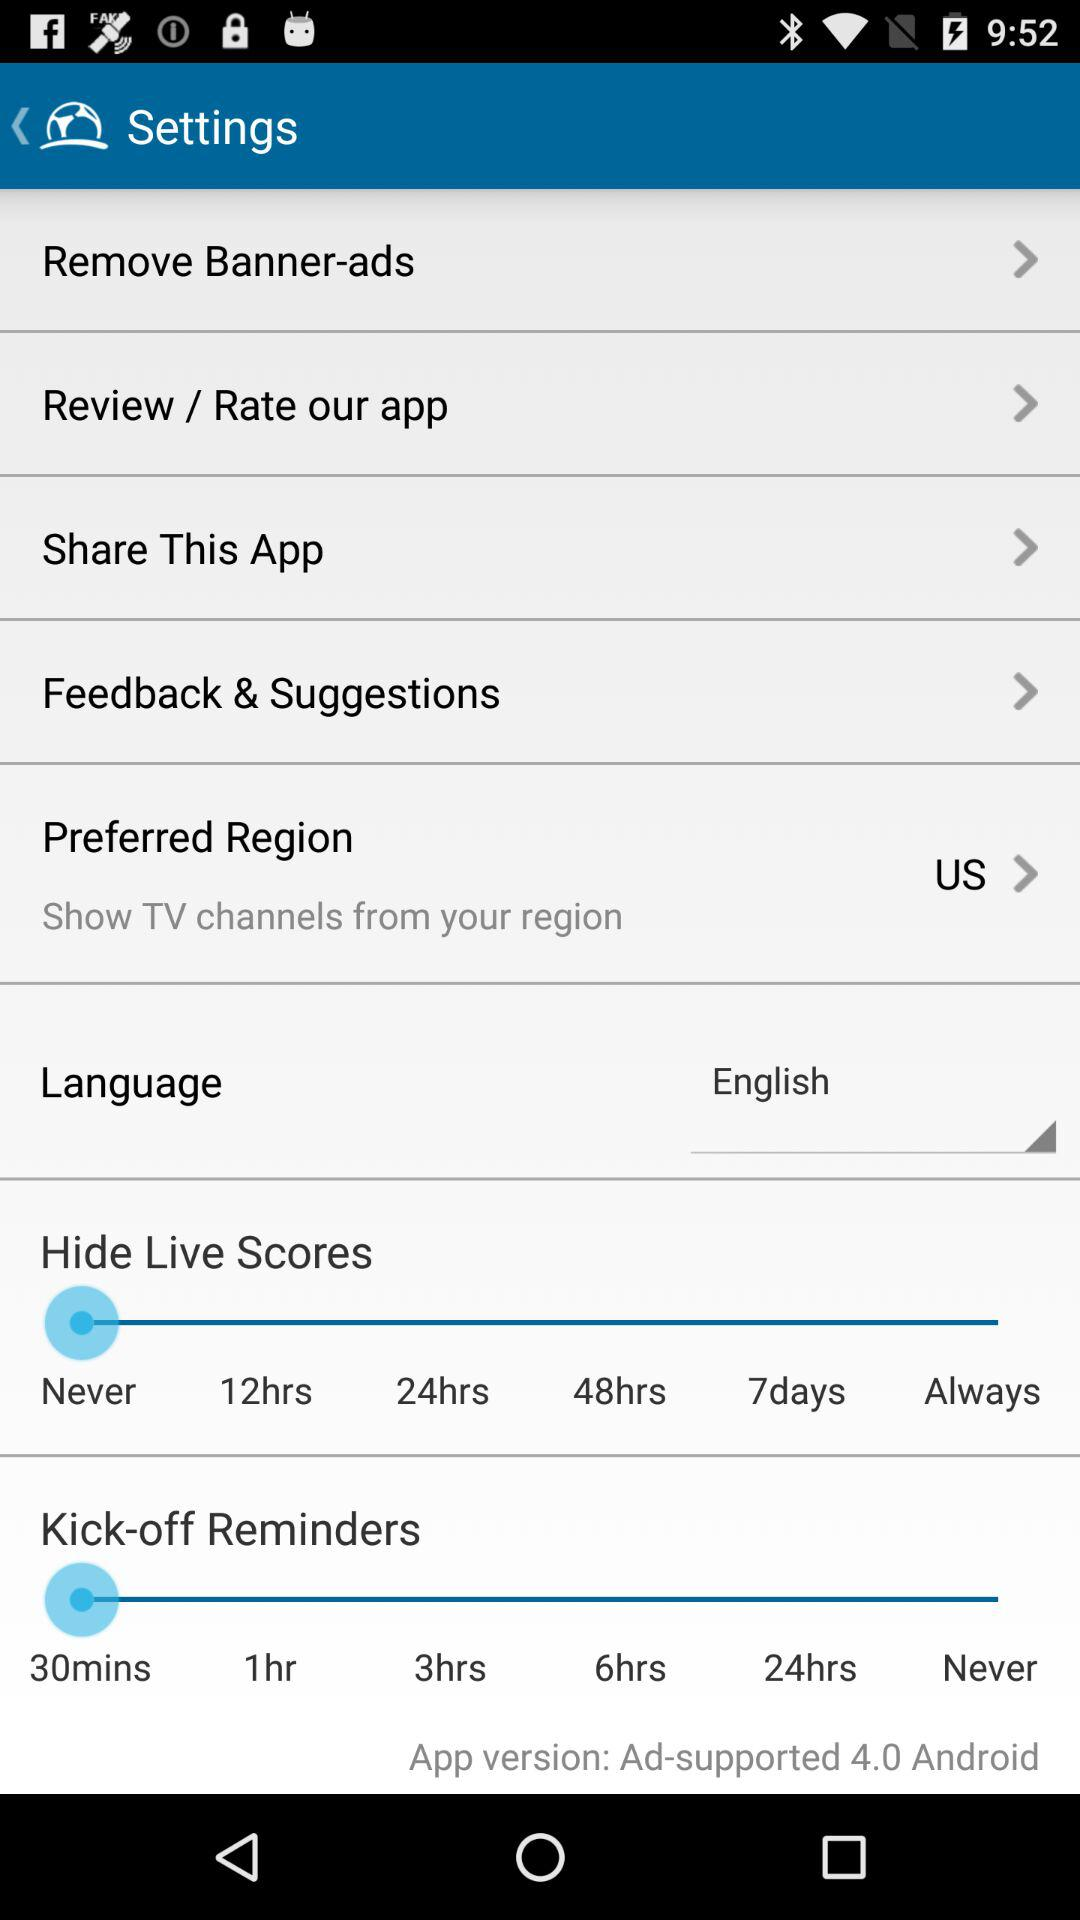Which version is it? The version is Ad-supported 4.0 Android. 